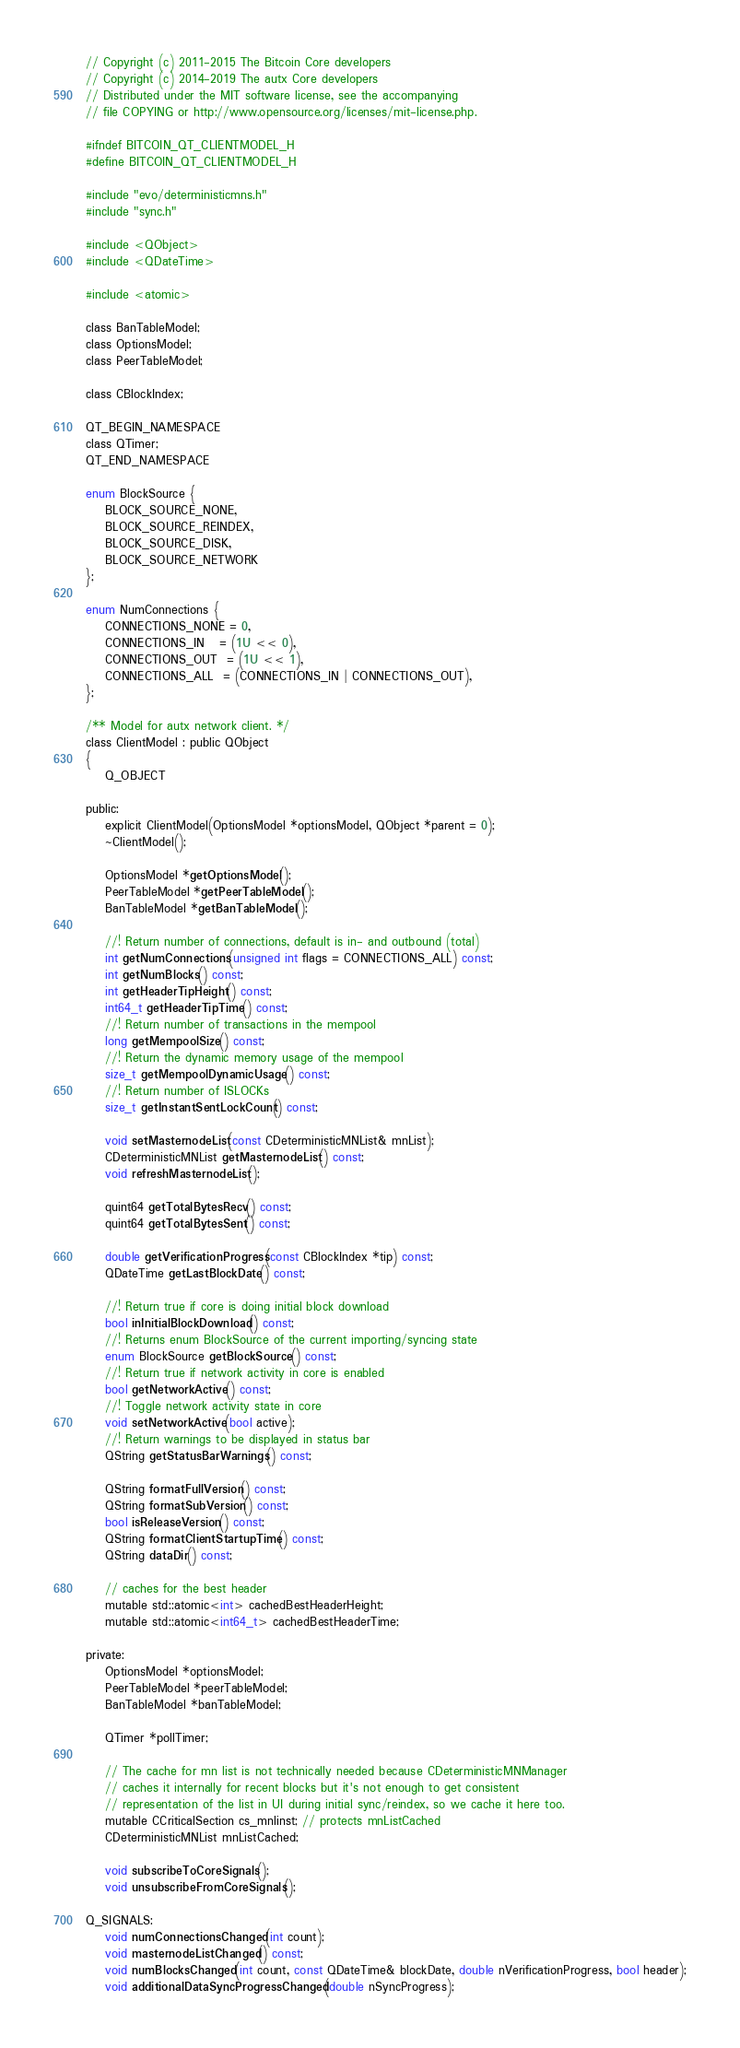<code> <loc_0><loc_0><loc_500><loc_500><_C_>// Copyright (c) 2011-2015 The Bitcoin Core developers
// Copyright (c) 2014-2019 The autx Core developers
// Distributed under the MIT software license, see the accompanying
// file COPYING or http://www.opensource.org/licenses/mit-license.php.

#ifndef BITCOIN_QT_CLIENTMODEL_H
#define BITCOIN_QT_CLIENTMODEL_H

#include "evo/deterministicmns.h"
#include "sync.h"

#include <QObject>
#include <QDateTime>

#include <atomic>

class BanTableModel;
class OptionsModel;
class PeerTableModel;

class CBlockIndex;

QT_BEGIN_NAMESPACE
class QTimer;
QT_END_NAMESPACE

enum BlockSource {
    BLOCK_SOURCE_NONE,
    BLOCK_SOURCE_REINDEX,
    BLOCK_SOURCE_DISK,
    BLOCK_SOURCE_NETWORK
};

enum NumConnections {
    CONNECTIONS_NONE = 0,
    CONNECTIONS_IN   = (1U << 0),
    CONNECTIONS_OUT  = (1U << 1),
    CONNECTIONS_ALL  = (CONNECTIONS_IN | CONNECTIONS_OUT),
};

/** Model for autx network client. */
class ClientModel : public QObject
{
    Q_OBJECT

public:
    explicit ClientModel(OptionsModel *optionsModel, QObject *parent = 0);
    ~ClientModel();

    OptionsModel *getOptionsModel();
    PeerTableModel *getPeerTableModel();
    BanTableModel *getBanTableModel();

    //! Return number of connections, default is in- and outbound (total)
    int getNumConnections(unsigned int flags = CONNECTIONS_ALL) const;
    int getNumBlocks() const;
    int getHeaderTipHeight() const;
    int64_t getHeaderTipTime() const;
    //! Return number of transactions in the mempool
    long getMempoolSize() const;
    //! Return the dynamic memory usage of the mempool
    size_t getMempoolDynamicUsage() const;
    //! Return number of ISLOCKs
    size_t getInstantSentLockCount() const;

    void setMasternodeList(const CDeterministicMNList& mnList);
    CDeterministicMNList getMasternodeList() const;
    void refreshMasternodeList();

    quint64 getTotalBytesRecv() const;
    quint64 getTotalBytesSent() const;

    double getVerificationProgress(const CBlockIndex *tip) const;
    QDateTime getLastBlockDate() const;

    //! Return true if core is doing initial block download
    bool inInitialBlockDownload() const;
    //! Returns enum BlockSource of the current importing/syncing state
    enum BlockSource getBlockSource() const;
    //! Return true if network activity in core is enabled
    bool getNetworkActive() const;
    //! Toggle network activity state in core
    void setNetworkActive(bool active);
    //! Return warnings to be displayed in status bar
    QString getStatusBarWarnings() const;

    QString formatFullVersion() const;
    QString formatSubVersion() const;
    bool isReleaseVersion() const;
    QString formatClientStartupTime() const;
    QString dataDir() const;

    // caches for the best header
    mutable std::atomic<int> cachedBestHeaderHeight;
    mutable std::atomic<int64_t> cachedBestHeaderTime;

private:
    OptionsModel *optionsModel;
    PeerTableModel *peerTableModel;
    BanTableModel *banTableModel;

    QTimer *pollTimer;

    // The cache for mn list is not technically needed because CDeterministicMNManager
    // caches it internally for recent blocks but it's not enough to get consistent
    // representation of the list in UI during initial sync/reindex, so we cache it here too.
    mutable CCriticalSection cs_mnlinst; // protects mnListCached
    CDeterministicMNList mnListCached;

    void subscribeToCoreSignals();
    void unsubscribeFromCoreSignals();

Q_SIGNALS:
    void numConnectionsChanged(int count);
    void masternodeListChanged() const;
    void numBlocksChanged(int count, const QDateTime& blockDate, double nVerificationProgress, bool header);
    void additionalDataSyncProgressChanged(double nSyncProgress);</code> 